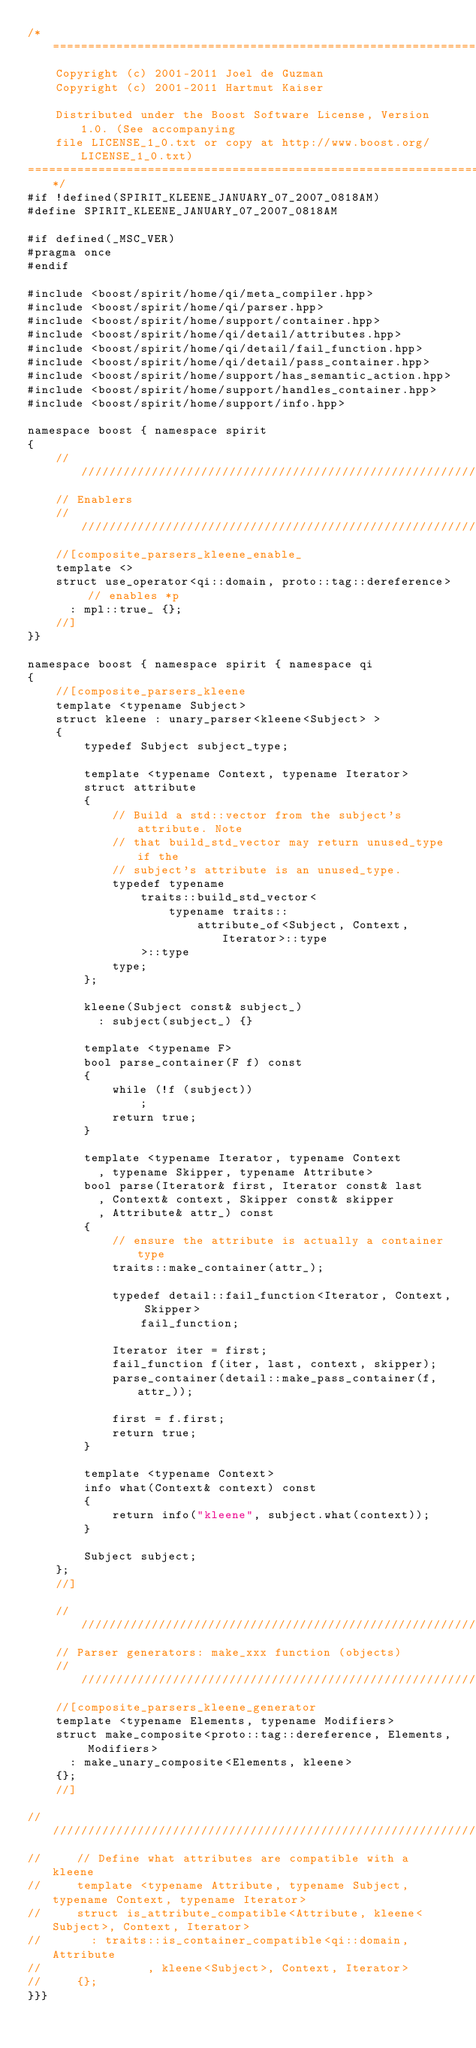Convert code to text. <code><loc_0><loc_0><loc_500><loc_500><_C++_>/*=============================================================================
    Copyright (c) 2001-2011 Joel de Guzman
    Copyright (c) 2001-2011 Hartmut Kaiser

    Distributed under the Boost Software License, Version 1.0. (See accompanying
    file LICENSE_1_0.txt or copy at http://www.boost.org/LICENSE_1_0.txt)
=============================================================================*/
#if !defined(SPIRIT_KLEENE_JANUARY_07_2007_0818AM)
#define SPIRIT_KLEENE_JANUARY_07_2007_0818AM

#if defined(_MSC_VER)
#pragma once
#endif

#include <boost/spirit/home/qi/meta_compiler.hpp>
#include <boost/spirit/home/qi/parser.hpp>
#include <boost/spirit/home/support/container.hpp>
#include <boost/spirit/home/qi/detail/attributes.hpp>
#include <boost/spirit/home/qi/detail/fail_function.hpp>
#include <boost/spirit/home/qi/detail/pass_container.hpp>
#include <boost/spirit/home/support/has_semantic_action.hpp>
#include <boost/spirit/home/support/handles_container.hpp>
#include <boost/spirit/home/support/info.hpp>

namespace boost { namespace spirit
{
    ///////////////////////////////////////////////////////////////////////////
    // Enablers
    ///////////////////////////////////////////////////////////////////////////
    //[composite_parsers_kleene_enable_
    template <>
    struct use_operator<qi::domain, proto::tag::dereference> // enables *p
      : mpl::true_ {};
    //]
}}

namespace boost { namespace spirit { namespace qi
{
    //[composite_parsers_kleene
    template <typename Subject>
    struct kleene : unary_parser<kleene<Subject> >
    {
        typedef Subject subject_type;

        template <typename Context, typename Iterator>
        struct attribute
        {
            // Build a std::vector from the subject's attribute. Note
            // that build_std_vector may return unused_type if the
            // subject's attribute is an unused_type.
            typedef typename
                traits::build_std_vector<
                    typename traits::
                        attribute_of<Subject, Context, Iterator>::type
                >::type
            type;
        };

        kleene(Subject const& subject_)
          : subject(subject_) {}

        template <typename F>
        bool parse_container(F f) const
        {
            while (!f (subject))
                ;
            return true;
        }

        template <typename Iterator, typename Context
          , typename Skipper, typename Attribute>
        bool parse(Iterator& first, Iterator const& last
          , Context& context, Skipper const& skipper
          , Attribute& attr_) const
        {
            // ensure the attribute is actually a container type
            traits::make_container(attr_);

            typedef detail::fail_function<Iterator, Context, Skipper>
                fail_function;

            Iterator iter = first;
            fail_function f(iter, last, context, skipper);
            parse_container(detail::make_pass_container(f, attr_));

            first = f.first;
            return true;
        }

        template <typename Context>
        info what(Context& context) const
        {
            return info("kleene", subject.what(context));
        }

        Subject subject;
    };
    //]

    ///////////////////////////////////////////////////////////////////////////
    // Parser generators: make_xxx function (objects)
    ///////////////////////////////////////////////////////////////////////////
    //[composite_parsers_kleene_generator
    template <typename Elements, typename Modifiers>
    struct make_composite<proto::tag::dereference, Elements, Modifiers>
      : make_unary_composite<Elements, kleene>
    {};
    //]

//     ///////////////////////////////////////////////////////////////////////////
//     // Define what attributes are compatible with a kleene
//     template <typename Attribute, typename Subject, typename Context, typename Iterator>
//     struct is_attribute_compatible<Attribute, kleene<Subject>, Context, Iterator>
//       : traits::is_container_compatible<qi::domain, Attribute
//               , kleene<Subject>, Context, Iterator>
//     {};
}}}
</code> 